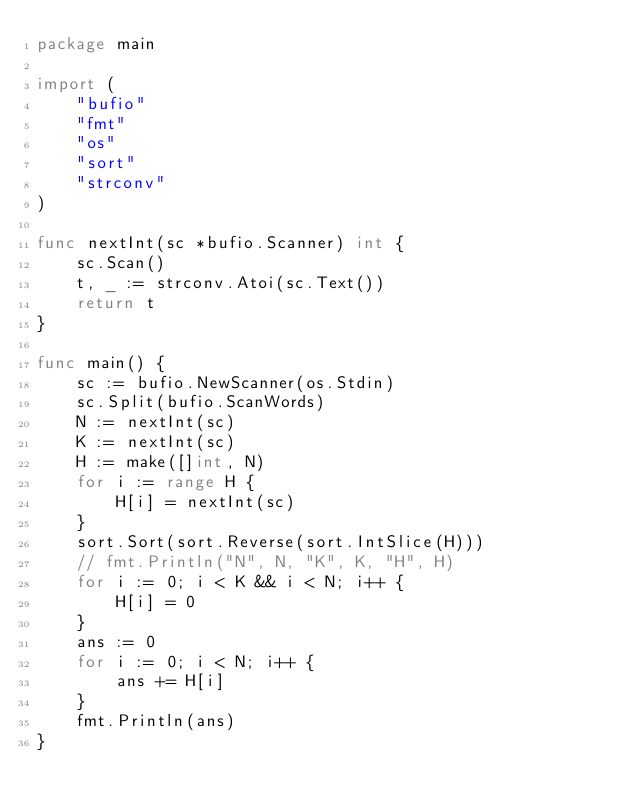Convert code to text. <code><loc_0><loc_0><loc_500><loc_500><_Go_>package main

import (
	"bufio"
	"fmt"
	"os"
	"sort"
	"strconv"
)

func nextInt(sc *bufio.Scanner) int {
	sc.Scan()
	t, _ := strconv.Atoi(sc.Text())
	return t
}

func main() {
	sc := bufio.NewScanner(os.Stdin)
	sc.Split(bufio.ScanWords)
	N := nextInt(sc)
	K := nextInt(sc)
	H := make([]int, N)
	for i := range H {
		H[i] = nextInt(sc)
	}
	sort.Sort(sort.Reverse(sort.IntSlice(H)))
	// fmt.Println("N", N, "K", K, "H", H)
	for i := 0; i < K && i < N; i++ {
		H[i] = 0
	}
	ans := 0
	for i := 0; i < N; i++ {
		ans += H[i]
	}
	fmt.Println(ans)
}
</code> 